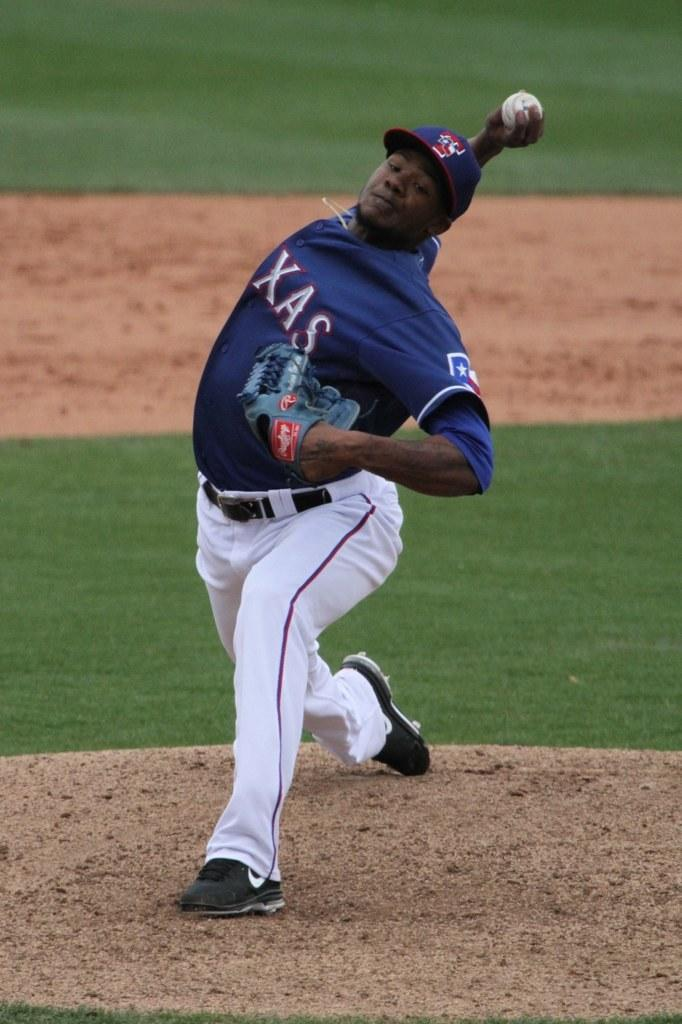What is the main subject of the image? There is a baseball player in the image. What is the baseball player doing in the image? The baseball player is standing on the ground and throwing a ball. What type of marble is the baseball player holding in the image? There is no marble present in the image; the baseball player is throwing a ball. What is the baseball player's need for a winter coat in the image? There is no mention of winter or a need for a coat in the image; the baseball player is simply throwing a ball. 